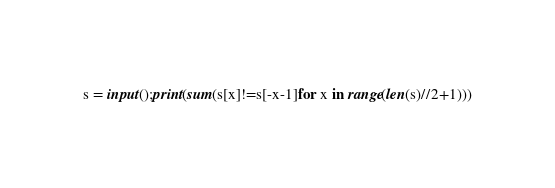Convert code to text. <code><loc_0><loc_0><loc_500><loc_500><_Python_>s = input();print(sum(s[x]!=s[-x-1]for x in range(len(s)//2+1)))</code> 